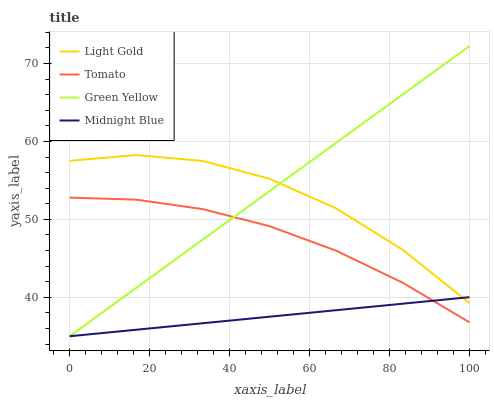Does Midnight Blue have the minimum area under the curve?
Answer yes or no. Yes. Does Green Yellow have the maximum area under the curve?
Answer yes or no. Yes. Does Light Gold have the minimum area under the curve?
Answer yes or no. No. Does Light Gold have the maximum area under the curve?
Answer yes or no. No. Is Green Yellow the smoothest?
Answer yes or no. Yes. Is Light Gold the roughest?
Answer yes or no. Yes. Is Light Gold the smoothest?
Answer yes or no. No. Is Green Yellow the roughest?
Answer yes or no. No. Does Green Yellow have the lowest value?
Answer yes or no. Yes. Does Light Gold have the lowest value?
Answer yes or no. No. Does Green Yellow have the highest value?
Answer yes or no. Yes. Does Light Gold have the highest value?
Answer yes or no. No. Is Tomato less than Light Gold?
Answer yes or no. Yes. Is Light Gold greater than Tomato?
Answer yes or no. Yes. Does Green Yellow intersect Midnight Blue?
Answer yes or no. Yes. Is Green Yellow less than Midnight Blue?
Answer yes or no. No. Is Green Yellow greater than Midnight Blue?
Answer yes or no. No. Does Tomato intersect Light Gold?
Answer yes or no. No. 